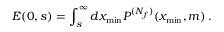Convert formula to latex. <formula><loc_0><loc_0><loc_500><loc_500>E ( 0 , s ) = \int _ { s } ^ { \infty } d x _ { \min } P ^ { ( N _ { f } ) } ( x _ { \min } , m ) \, .</formula> 